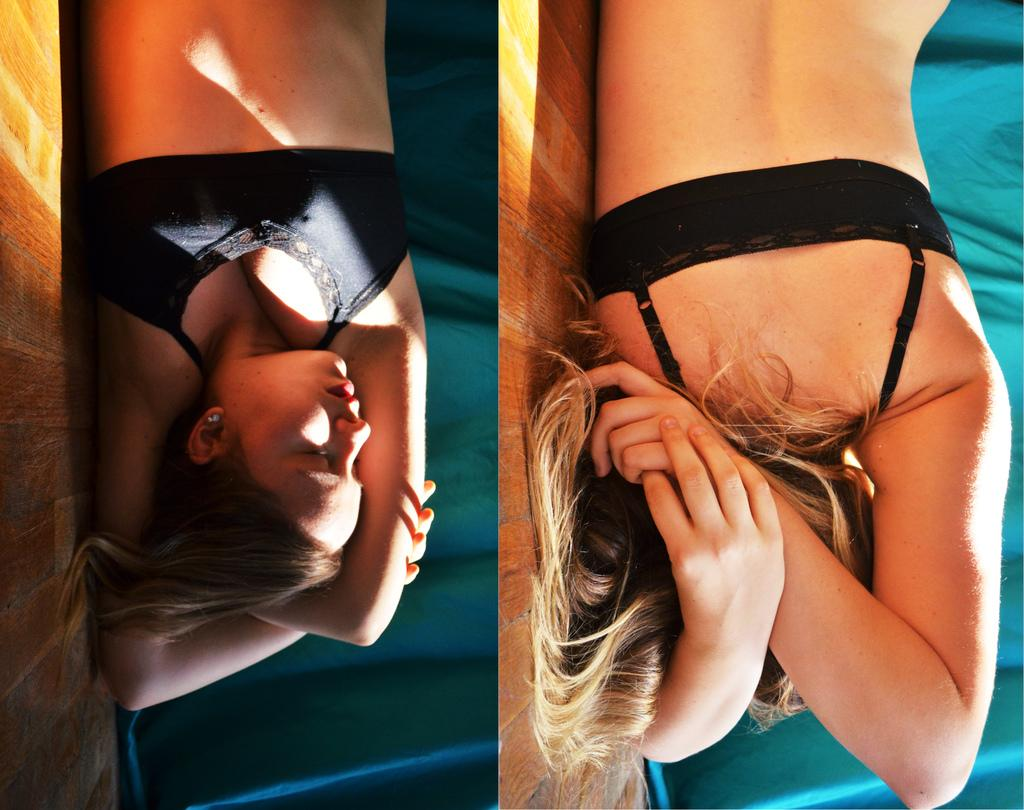What is the woman in the image doing? The woman is laying on the floor in the image. Can you describe the background of the image? There is a cloth in the background of the image. What is the size of the wren in the image? There is no wren present in the image. How many steps does the woman take in the image? The woman is laying on the floor and not taking any steps in the image. 